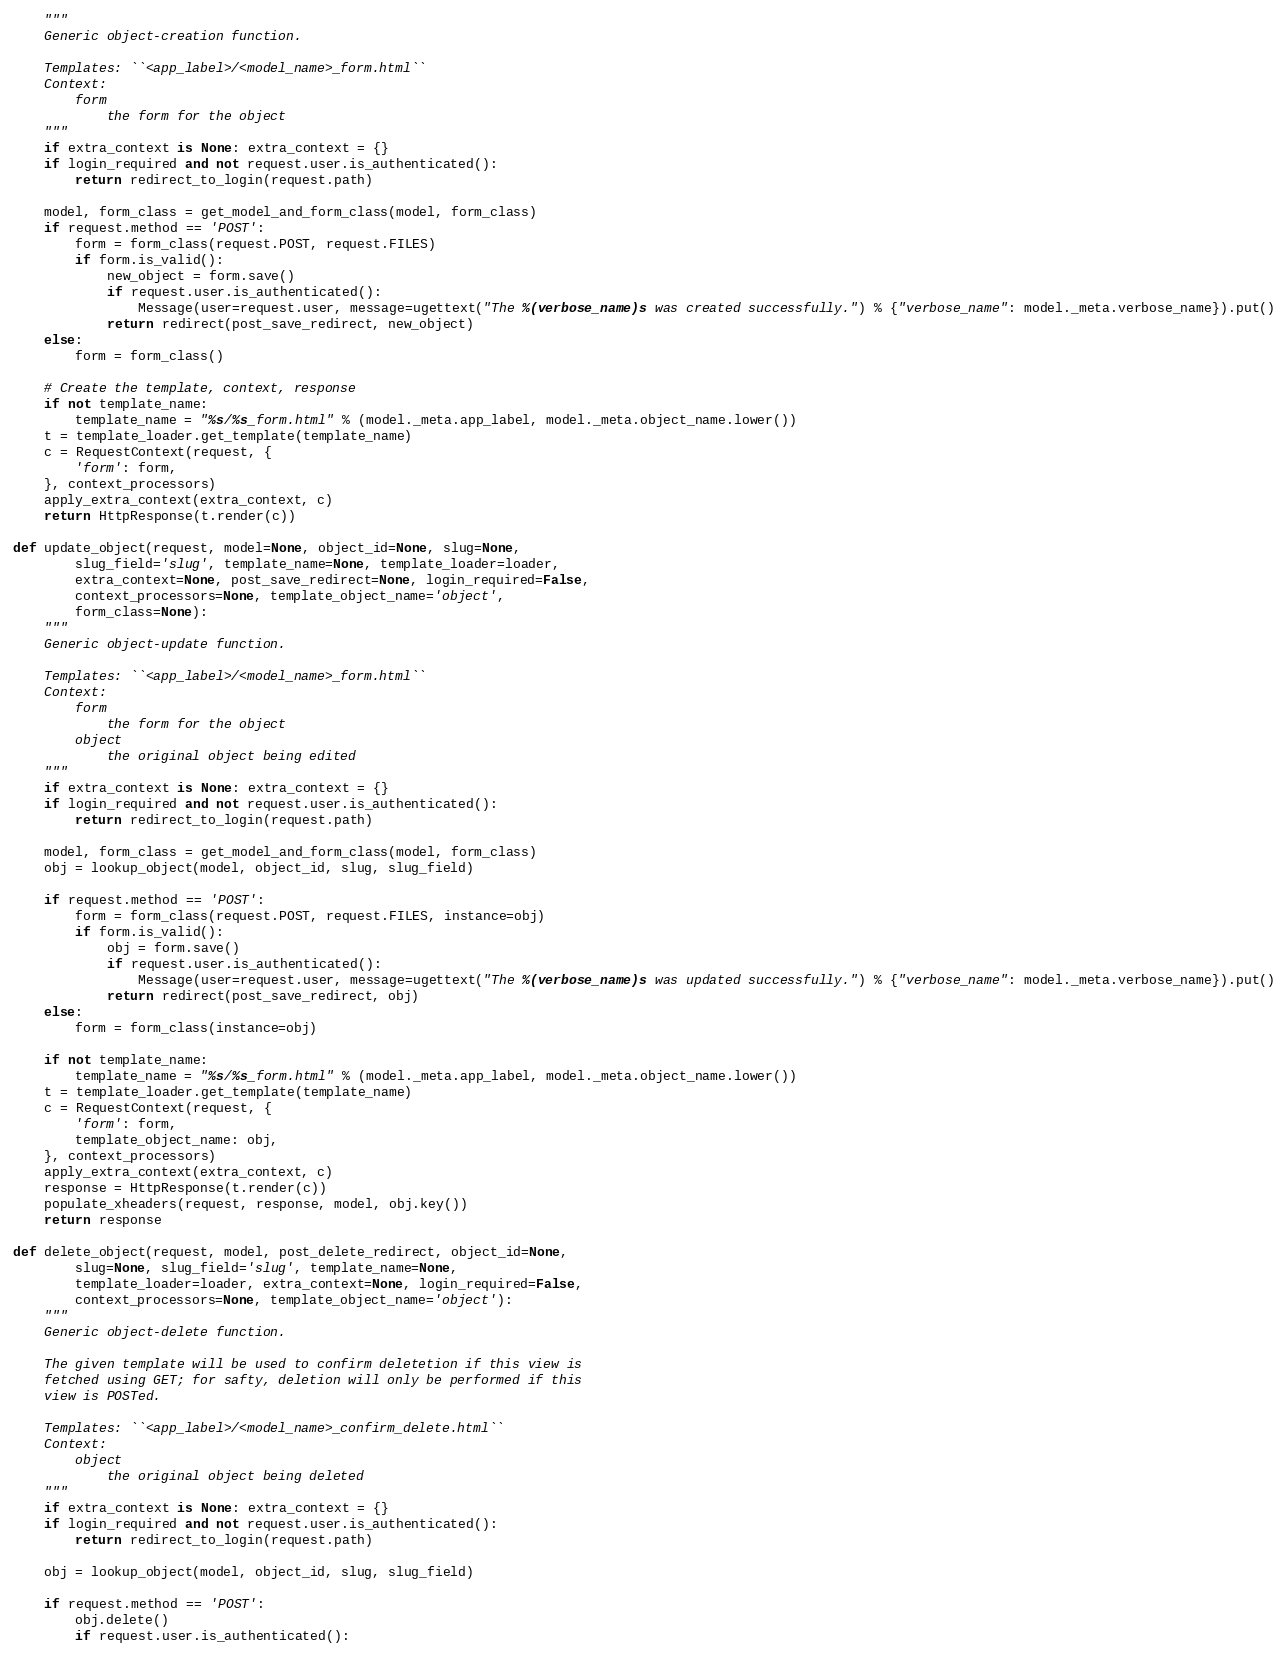<code> <loc_0><loc_0><loc_500><loc_500><_Python_>    """
    Generic object-creation function.

    Templates: ``<app_label>/<model_name>_form.html``
    Context:
        form
            the form for the object
    """
    if extra_context is None: extra_context = {}
    if login_required and not request.user.is_authenticated():
        return redirect_to_login(request.path)

    model, form_class = get_model_and_form_class(model, form_class)
    if request.method == 'POST':
        form = form_class(request.POST, request.FILES)
        if form.is_valid():
            new_object = form.save()
            if request.user.is_authenticated():
                Message(user=request.user, message=ugettext("The %(verbose_name)s was created successfully.") % {"verbose_name": model._meta.verbose_name}).put()
            return redirect(post_save_redirect, new_object)
    else:
        form = form_class()

    # Create the template, context, response
    if not template_name:
        template_name = "%s/%s_form.html" % (model._meta.app_label, model._meta.object_name.lower())
    t = template_loader.get_template(template_name)
    c = RequestContext(request, {
        'form': form,
    }, context_processors)
    apply_extra_context(extra_context, c)
    return HttpResponse(t.render(c))

def update_object(request, model=None, object_id=None, slug=None,
        slug_field='slug', template_name=None, template_loader=loader,
        extra_context=None, post_save_redirect=None, login_required=False,
        context_processors=None, template_object_name='object',
        form_class=None):
    """
    Generic object-update function.

    Templates: ``<app_label>/<model_name>_form.html``
    Context:
        form
            the form for the object
        object
            the original object being edited
    """
    if extra_context is None: extra_context = {}
    if login_required and not request.user.is_authenticated():
        return redirect_to_login(request.path)

    model, form_class = get_model_and_form_class(model, form_class)
    obj = lookup_object(model, object_id, slug, slug_field)

    if request.method == 'POST':
        form = form_class(request.POST, request.FILES, instance=obj)
        if form.is_valid():
            obj = form.save()
            if request.user.is_authenticated():
                Message(user=request.user, message=ugettext("The %(verbose_name)s was updated successfully.") % {"verbose_name": model._meta.verbose_name}).put()
            return redirect(post_save_redirect, obj)
    else:
        form = form_class(instance=obj)

    if not template_name:
        template_name = "%s/%s_form.html" % (model._meta.app_label, model._meta.object_name.lower())
    t = template_loader.get_template(template_name)
    c = RequestContext(request, {
        'form': form,
        template_object_name: obj,
    }, context_processors)
    apply_extra_context(extra_context, c)
    response = HttpResponse(t.render(c))
    populate_xheaders(request, response, model, obj.key())
    return response

def delete_object(request, model, post_delete_redirect, object_id=None,
        slug=None, slug_field='slug', template_name=None,
        template_loader=loader, extra_context=None, login_required=False,
        context_processors=None, template_object_name='object'):
    """
    Generic object-delete function.

    The given template will be used to confirm deletetion if this view is
    fetched using GET; for safty, deletion will only be performed if this
    view is POSTed.

    Templates: ``<app_label>/<model_name>_confirm_delete.html``
    Context:
        object
            the original object being deleted
    """
    if extra_context is None: extra_context = {}
    if login_required and not request.user.is_authenticated():
        return redirect_to_login(request.path)

    obj = lookup_object(model, object_id, slug, slug_field)

    if request.method == 'POST':
        obj.delete()
        if request.user.is_authenticated():</code> 